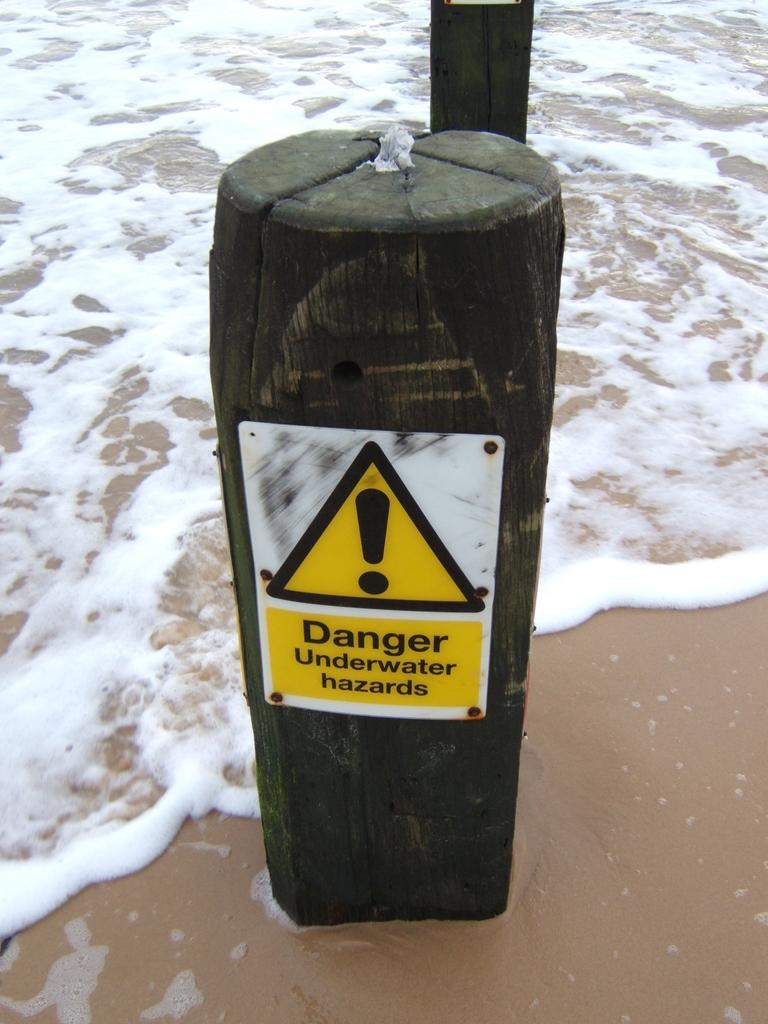<image>
Create a compact narrative representing the image presented. A post with a sign that says  Danger underwater hazards. 